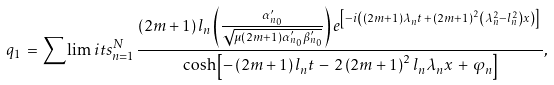<formula> <loc_0><loc_0><loc_500><loc_500>q _ { 1 } \, = \sum \lim i t s _ { n = 1 } ^ { N } \frac { \left ( 2 m + 1 \right ) l _ { n } \left ( \frac { \alpha _ { n _ { 0 } } ^ { \prime } } { \sqrt { \mu \left ( 2 m + 1 \right ) \alpha _ { n _ { 0 } } ^ { \prime } \beta _ { n _ { 0 } } ^ { \prime } } } \right ) e ^ { \left [ - i \left ( \left ( 2 m + 1 \right ) \lambda _ { n } t \, + \, \left ( 2 m + 1 \right ) ^ { 2 } \left ( \lambda _ { n } ^ { 2 } - l _ { n } ^ { 2 } \right ) x \right ) \right ] } \, } { \cosh \left [ - \left ( 2 m + 1 \right ) l _ { n } t \, - \, 2 \left ( 2 m + 1 \right ) ^ { 2 } l _ { n } \lambda _ { n } x \, + \, \varphi _ { n } \right ] } ,</formula> 